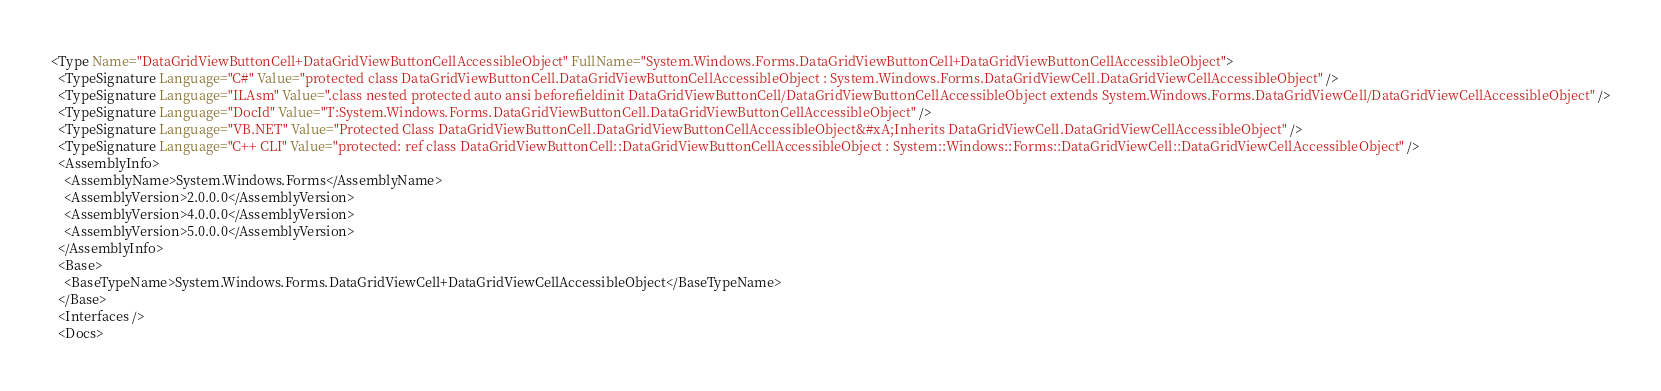Convert code to text. <code><loc_0><loc_0><loc_500><loc_500><_XML_><Type Name="DataGridViewButtonCell+DataGridViewButtonCellAccessibleObject" FullName="System.Windows.Forms.DataGridViewButtonCell+DataGridViewButtonCellAccessibleObject">
  <TypeSignature Language="C#" Value="protected class DataGridViewButtonCell.DataGridViewButtonCellAccessibleObject : System.Windows.Forms.DataGridViewCell.DataGridViewCellAccessibleObject" />
  <TypeSignature Language="ILAsm" Value=".class nested protected auto ansi beforefieldinit DataGridViewButtonCell/DataGridViewButtonCellAccessibleObject extends System.Windows.Forms.DataGridViewCell/DataGridViewCellAccessibleObject" />
  <TypeSignature Language="DocId" Value="T:System.Windows.Forms.DataGridViewButtonCell.DataGridViewButtonCellAccessibleObject" />
  <TypeSignature Language="VB.NET" Value="Protected Class DataGridViewButtonCell.DataGridViewButtonCellAccessibleObject&#xA;Inherits DataGridViewCell.DataGridViewCellAccessibleObject" />
  <TypeSignature Language="C++ CLI" Value="protected: ref class DataGridViewButtonCell::DataGridViewButtonCellAccessibleObject : System::Windows::Forms::DataGridViewCell::DataGridViewCellAccessibleObject" />
  <AssemblyInfo>
    <AssemblyName>System.Windows.Forms</AssemblyName>
    <AssemblyVersion>2.0.0.0</AssemblyVersion>
    <AssemblyVersion>4.0.0.0</AssemblyVersion>
    <AssemblyVersion>5.0.0.0</AssemblyVersion>
  </AssemblyInfo>
  <Base>
    <BaseTypeName>System.Windows.Forms.DataGridViewCell+DataGridViewCellAccessibleObject</BaseTypeName>
  </Base>
  <Interfaces />
  <Docs></code> 